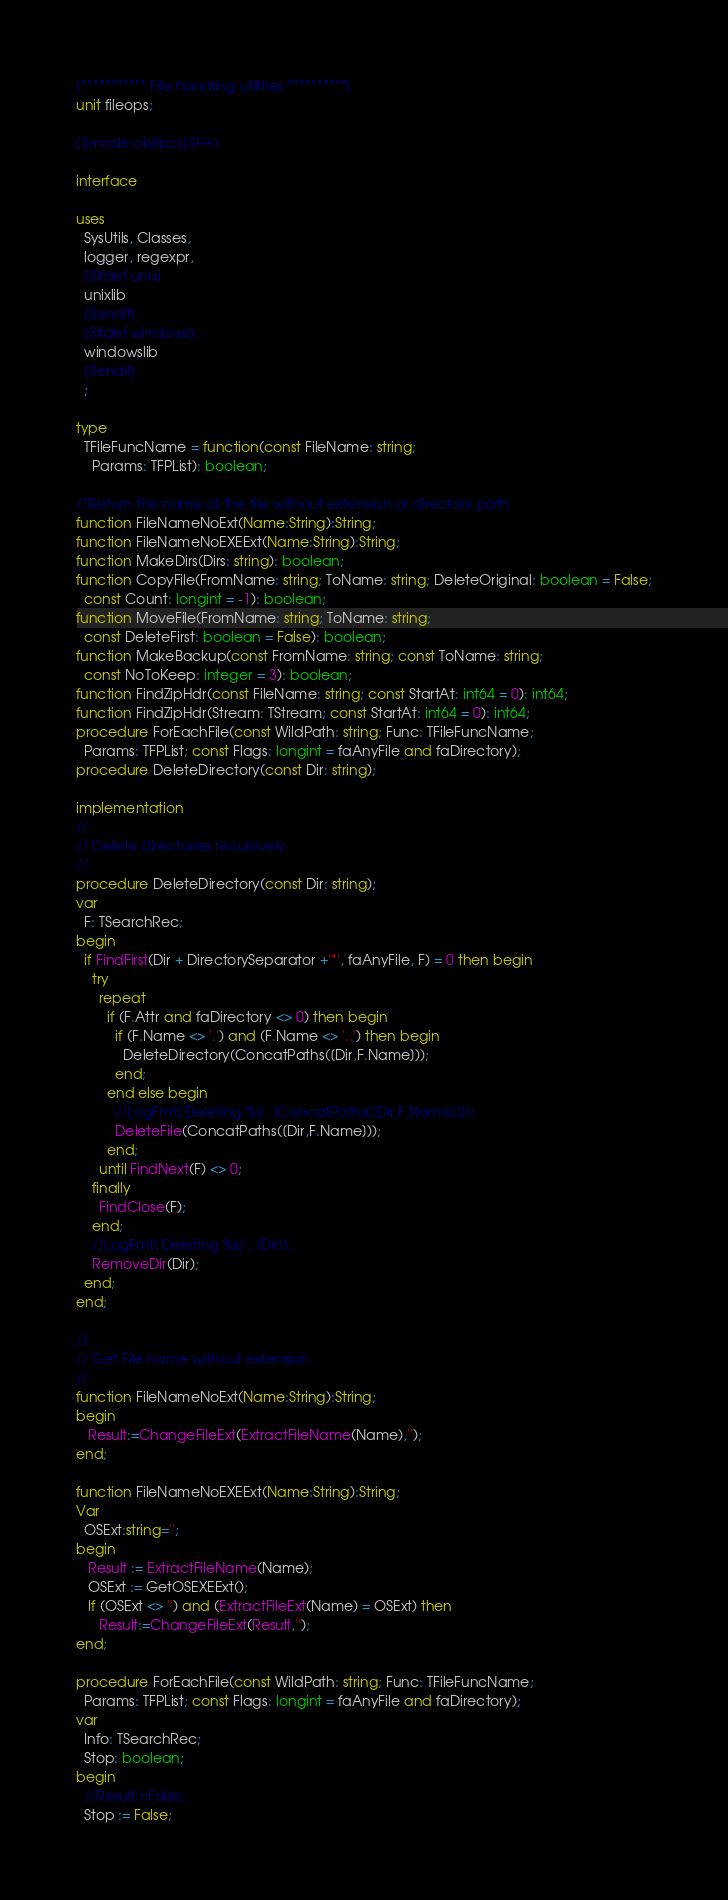<code> <loc_0><loc_0><loc_500><loc_500><_Pascal_>{*********** File handling utilities **********}
unit fileops;

{$mode objfpc}{$H+}

interface

uses
  SysUtils, Classes,
  logger, regexpr,
  {$ifdef unix}
  unixlib
  {$endif}
  {$ifdef windows}
  windowslib
  {$endif}
  ;

type
  TFileFuncName = function(const FileName: string;
    Params: TFPList): boolean;

//Return the name of the file without extension or directory path
function FileNameNoExt(Name:String):String;
function FileNameNoEXEExt(Name:String):String;
function MakeDirs(Dirs: string): boolean;
function CopyFile(FromName: string; ToName: string; DeleteOriginal: boolean = False;
  const Count: longint = -1): boolean;
function MoveFile(FromName: string; ToName: string;
  const DeleteFirst: boolean = False): boolean;
function MakeBackup(const FromName: string; const ToName: string;
  const NoToKeep: integer = 3): boolean;
function FindZipHdr(const FileName: string; const StartAt: int64 = 0): int64;
function FindZipHdr(Stream: TStream; const StartAt: int64 = 0): int64;
procedure ForEachFile(const WildPath: string; Func: TFileFuncName;
  Params: TFPList; const Flags: longint = faAnyFile and faDirectory);
procedure DeleteDirectory(const Dir: string);

implementation
//
// Delete directories recursively
//
procedure DeleteDirectory(const Dir: string);
var
  F: TSearchRec;
begin
  if FindFirst(Dir + DirectorySeparator +'*', faAnyFile, F) = 0 then begin
    try
      repeat
        if (F.Attr and faDirectory <> 0) then begin
          if (F.Name <> '.') and (F.Name <> '..') then begin
            DeleteDirectory(ConcatPaths([Dir,F.Name]));
          end;
        end else begin
          //LogFmt('Deleting %s', [ConcatPaths([Dir,F.Name])]);
          DeleteFile(ConcatPaths([Dir,F.Name]));
        end;
      until FindNext(F) <> 0;
    finally
      FindClose(F);
    end;
    //LogFmt('Deleting %s/', [Dir]);
    RemoveDir(Dir);
  end;
end;

//
// Get File name without extension
//
function FileNameNoExt(Name:String):String;
begin
   Result:=ChangeFileExt(ExtractFileName(Name),'');
end;

function FileNameNoEXEExt(Name:String):String;
Var
  OSExt:string='';
begin
   Result := ExtractFileName(Name);
   OSExt := GetOSEXEExt();
   If (OSExt <> '') and (ExtractFileExt(Name) = OSExt) then
      Result:=ChangeFileExt(Result,'');
end;

procedure ForEachFile(const WildPath: string; Func: TFileFuncName;
  Params: TFPList; const Flags: longint = faAnyFile and faDirectory);
var
  Info: TSearchRec;
  Stop: boolean;
begin
  //Result:=False;
  Stop := False;</code> 